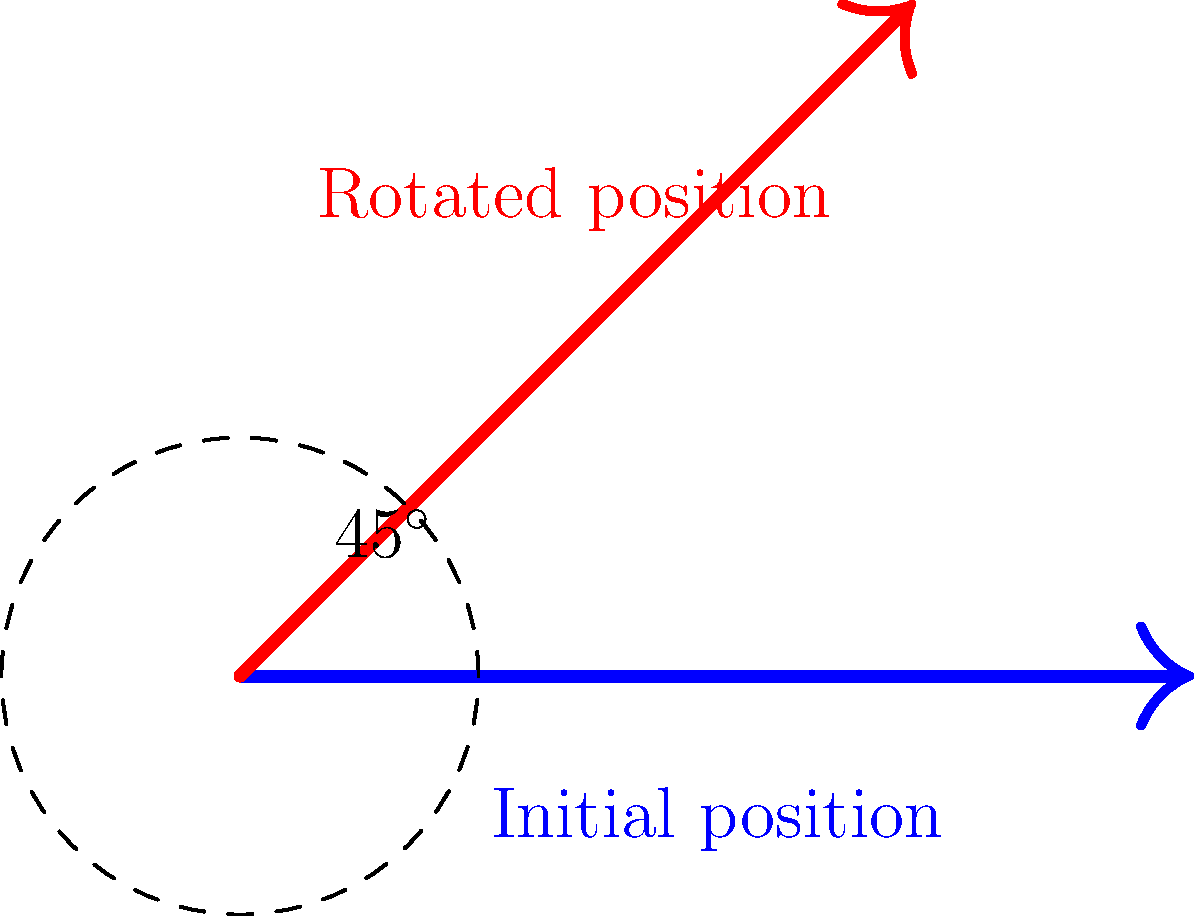In a CGI animation sequence, you need to rotate a character's arm by 45 degrees counterclockwise around its shoulder joint. Given the initial arm position vector $\mathbf{v} = [2, 0, 1]^T$, what is the resulting position vector after applying the appropriate 3D rotation matrix? To solve this problem, we'll follow these steps:

1) First, we need to identify the correct 3D rotation matrix. For a rotation of $\theta$ degrees around the z-axis (which is what we need for this 2D rotation in the xy-plane), the matrix is:

   $$R_z(\theta) = \begin{bmatrix}
   \cos\theta & -\sin\theta & 0 \\
   \sin\theta & \cos\theta & 0 \\
   0 & 0 & 1
   \end{bmatrix}$$

2) We're rotating by 45°, so $\theta = 45° = \frac{\pi}{4}$ radians. Let's substitute this:

   $$R_z(\frac{\pi}{4}) = \begin{bmatrix}
   \cos(\frac{\pi}{4}) & -\sin(\frac{\pi}{4}) & 0 \\
   \sin(\frac{\pi}{4}) & \cos(\frac{\pi}{4}) & 0 \\
   0 & 0 & 1
   \end{bmatrix}$$

3) We know that $\cos(\frac{\pi}{4}) = \sin(\frac{\pi}{4}) = \frac{\sqrt{2}}{2}$, so our matrix becomes:

   $$R_z(\frac{\pi}{4}) = \begin{bmatrix}
   \frac{\sqrt{2}}{2} & -\frac{\sqrt{2}}{2} & 0 \\
   \frac{\sqrt{2}}{2} & \frac{\sqrt{2}}{2} & 0 \\
   0 & 0 & 1
   \end{bmatrix}$$

4) Now, we multiply this matrix by our initial position vector:

   $$\begin{bmatrix}
   \frac{\sqrt{2}}{2} & -\frac{\sqrt{2}}{2} & 0 \\
   \frac{\sqrt{2}}{2} & \frac{\sqrt{2}}{2} & 0 \\
   0 & 0 & 1
   \end{bmatrix} \begin{bmatrix}
   2 \\
   0 \\
   1
   \end{bmatrix}$$

5) Performing the matrix multiplication:

   $$\begin{bmatrix}
   (2 \cdot \frac{\sqrt{2}}{2}) + (0 \cdot -\frac{\sqrt{2}}{2}) + (1 \cdot 0) \\
   (2 \cdot \frac{\sqrt{2}}{2}) + (0 \cdot \frac{\sqrt{2}}{2}) + (1 \cdot 0) \\
   (2 \cdot 0) + (0 \cdot 0) + (1 \cdot 1)
   \end{bmatrix} = \begin{bmatrix}
   \sqrt{2} \\
   \sqrt{2} \\
   1
   \end{bmatrix}$$

Therefore, the resulting position vector after rotation is $[\sqrt{2}, \sqrt{2}, 1]^T$.
Answer: $[\sqrt{2}, \sqrt{2}, 1]^T$ 